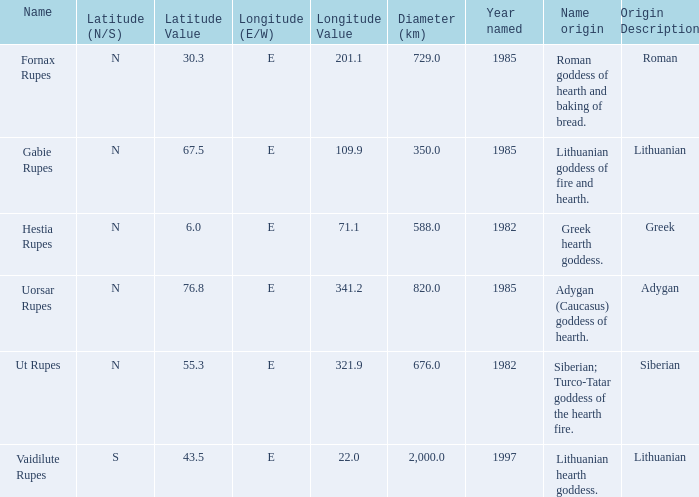What is the latitude of the features located at a longitude of 321.9 degrees east? 55.3N. 